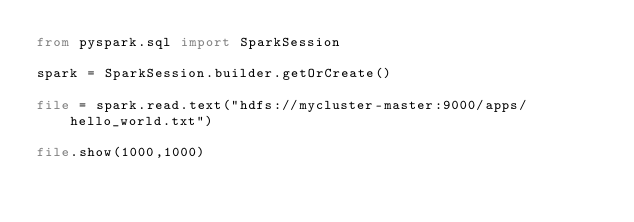<code> <loc_0><loc_0><loc_500><loc_500><_Python_>from pyspark.sql import SparkSession

spark = SparkSession.builder.getOrCreate()

file = spark.read.text("hdfs://mycluster-master:9000/apps/hello_world.txt")

file.show(1000,1000)

</code> 